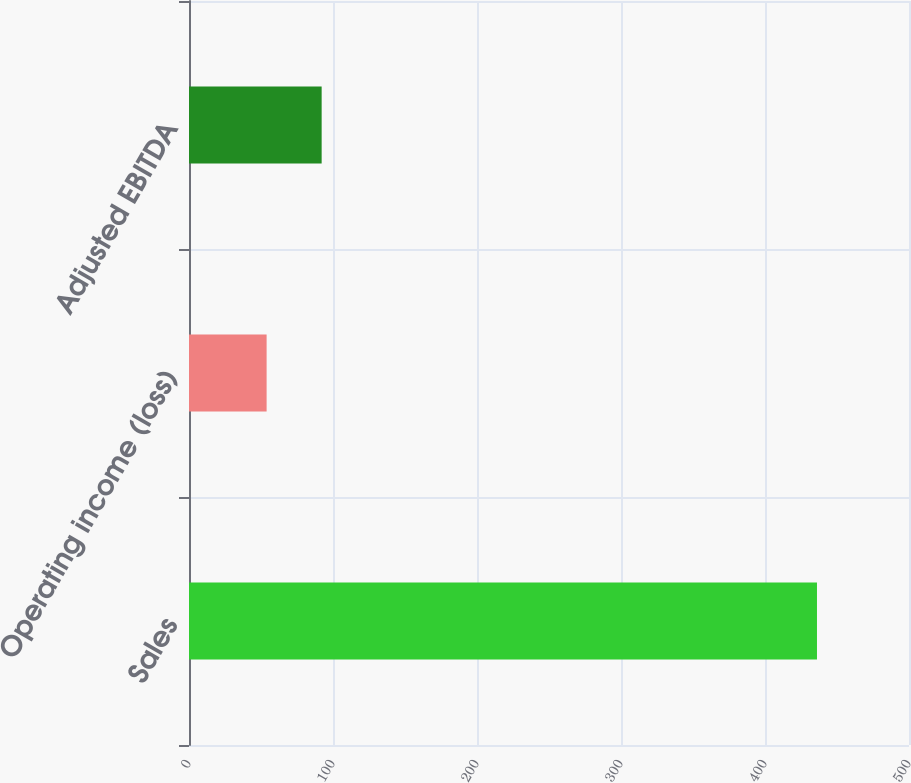<chart> <loc_0><loc_0><loc_500><loc_500><bar_chart><fcel>Sales<fcel>Operating income (loss)<fcel>Adjusted EBITDA<nl><fcel>436.1<fcel>53.9<fcel>92.12<nl></chart> 